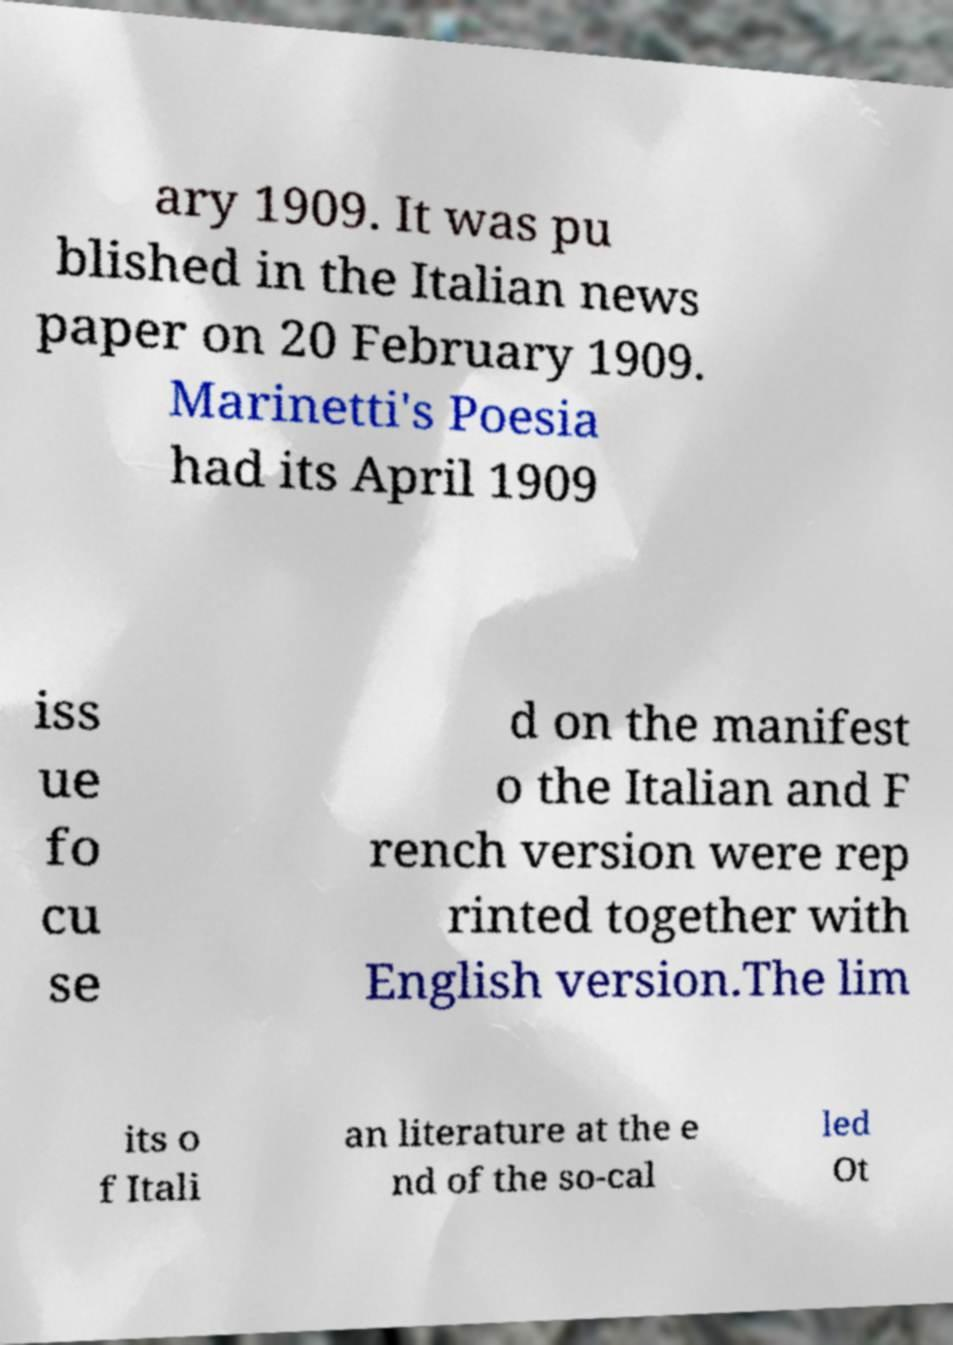I need the written content from this picture converted into text. Can you do that? ary 1909. It was pu blished in the Italian news paper on 20 February 1909. Marinetti's Poesia had its April 1909 iss ue fo cu se d on the manifest o the Italian and F rench version were rep rinted together with English version.The lim its o f Itali an literature at the e nd of the so-cal led Ot 